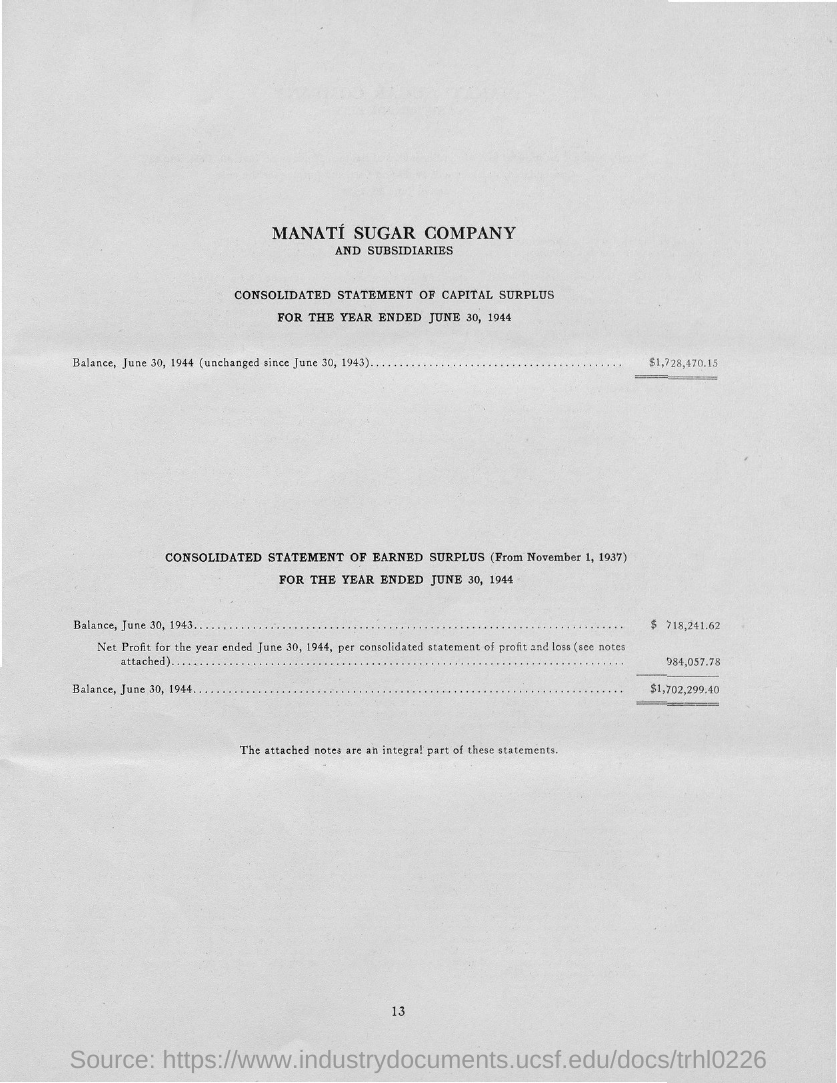List a handful of essential elements in this visual. The page number is 13. 